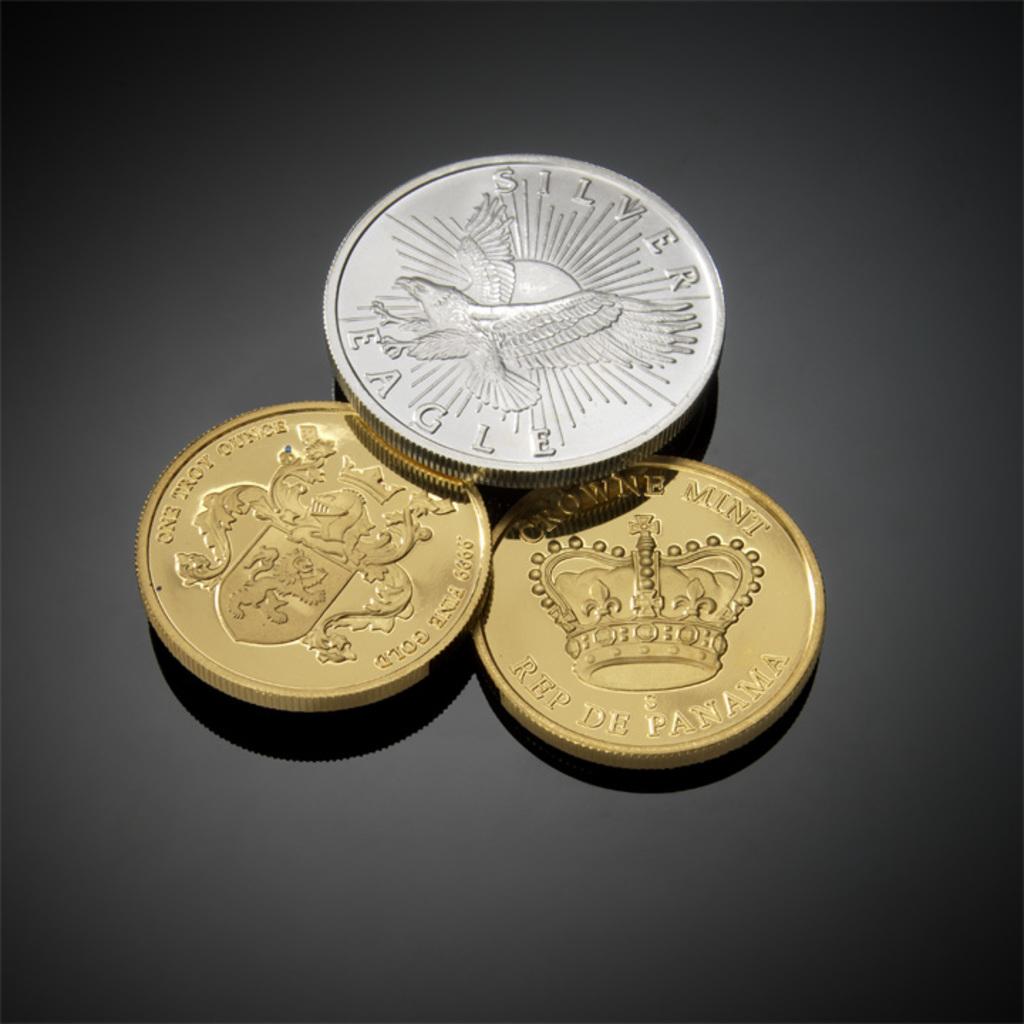What bird is on the silver coin?
Your response must be concise. Eagle. What is written on the silver coin?
Provide a succinct answer. Silver eagle. 